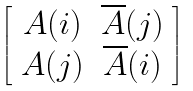Convert formula to latex. <formula><loc_0><loc_0><loc_500><loc_500>\left [ \begin{array} { c c } A ( i ) & \overline { A } ( j ) \\ A ( j ) & \overline { A } ( i ) \end{array} \right ]</formula> 